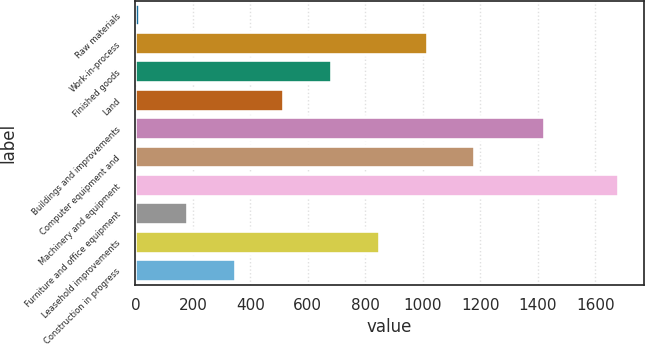Convert chart. <chart><loc_0><loc_0><loc_500><loc_500><bar_chart><fcel>Raw materials<fcel>Work-in-process<fcel>Finished goods<fcel>Land<fcel>Buildings and improvements<fcel>Computer equipment and<fcel>Machinery and equipment<fcel>Furniture and office equipment<fcel>Leasehold improvements<fcel>Construction in progress<nl><fcel>15<fcel>1016.4<fcel>682.6<fcel>515.7<fcel>1424<fcel>1183.3<fcel>1684<fcel>181.9<fcel>849.5<fcel>348.8<nl></chart> 